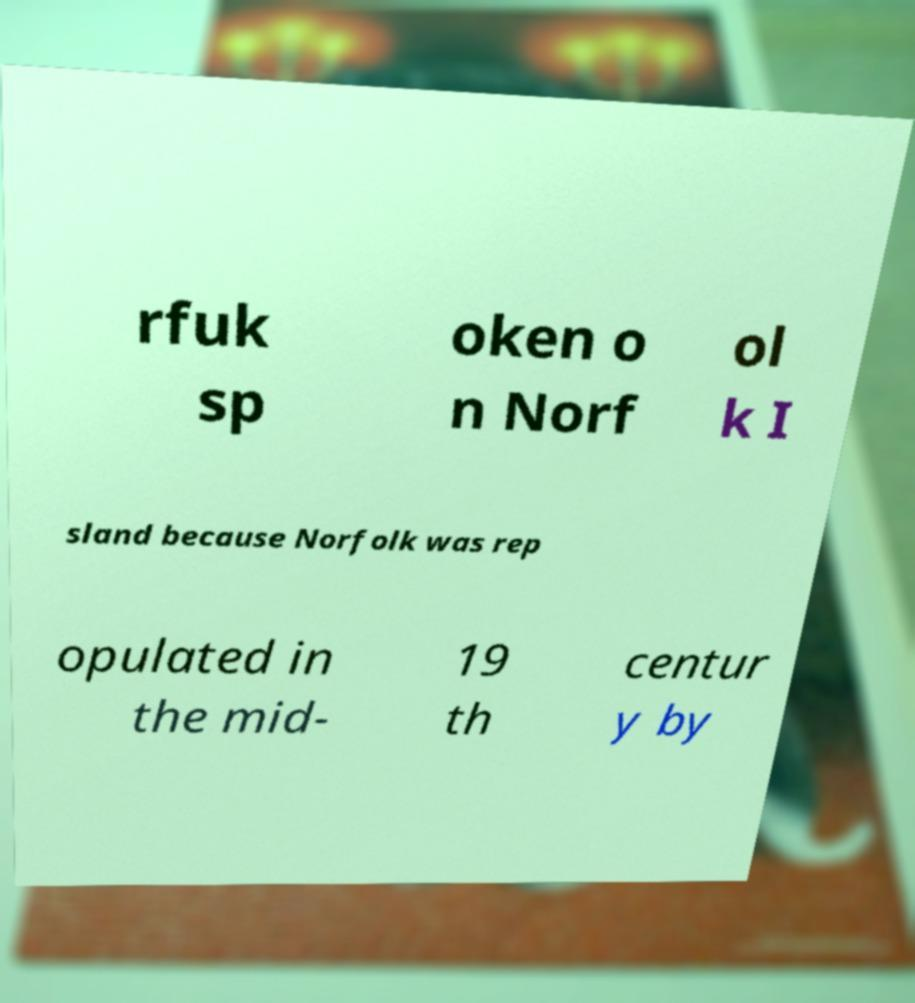Could you extract and type out the text from this image? rfuk sp oken o n Norf ol k I sland because Norfolk was rep opulated in the mid- 19 th centur y by 